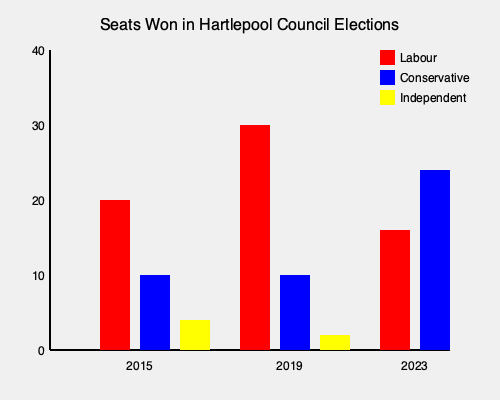Based on the bar graph showing the number of seats won by different parties in the Hartlepool Council elections over the past three elections, which party has shown the most significant change in seat count from 2019 to 2023, and by how many seats? To determine which party has shown the most significant change in seat count from 2019 to 2023, we need to:

1. Calculate the change in seats for each party:

   Labour:
   2019: 30 seats
   2023: 16 seats
   Change: 30 - 16 = 14 seat decrease

   Conservative:
   2019: 10 seats
   2023: 24 seats
   Change: 24 - 10 = 14 seat increase

   Independent:
   2019: 2 seats
   2023: 0 seats (not visible on the graph)
   Change: 0 - 2 = 2 seat decrease

2. Compare the absolute values of these changes:
   Labour: |14|
   Conservative: |14|
   Independent: |2|

3. Identify the largest change:
   Both Labour and Conservative have the largest change of 14 seats.

4. Since the question asks for the most significant change, we need to consider both the magnitude and the direction of the change. In this case, the Conservative party's increase of 14 seats represents a more significant change than Labour's decrease of 14 seats, as it shows a growing trend for the party.
Answer: Conservative party, 14 seat increase 